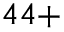Convert formula to latex. <formula><loc_0><loc_0><loc_500><loc_500>^ { 4 4 + }</formula> 